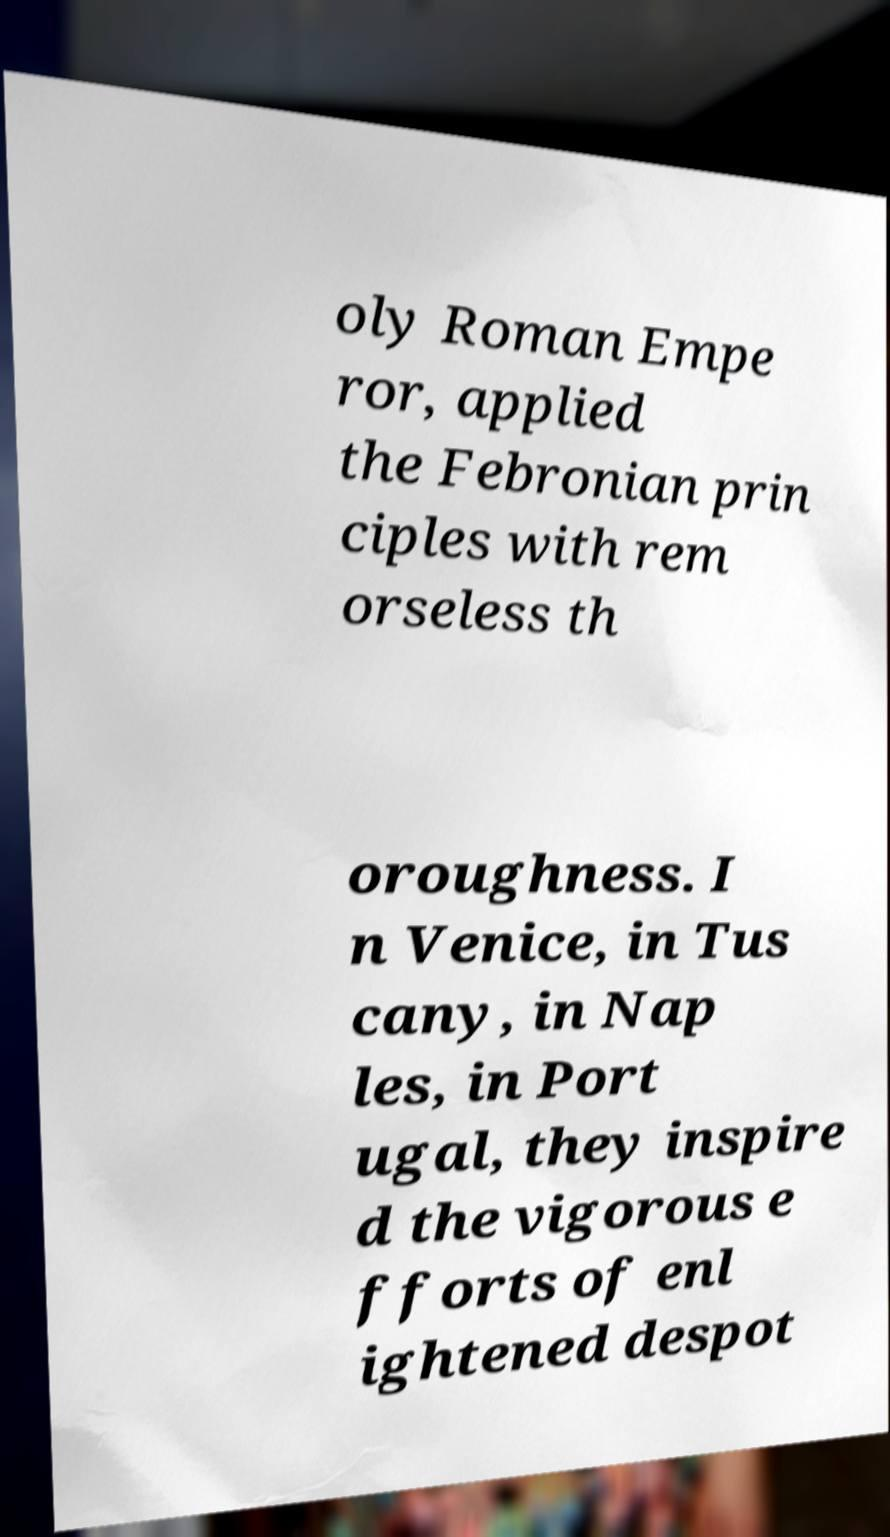Could you assist in decoding the text presented in this image and type it out clearly? oly Roman Empe ror, applied the Febronian prin ciples with rem orseless th oroughness. I n Venice, in Tus cany, in Nap les, in Port ugal, they inspire d the vigorous e fforts of enl ightened despot 